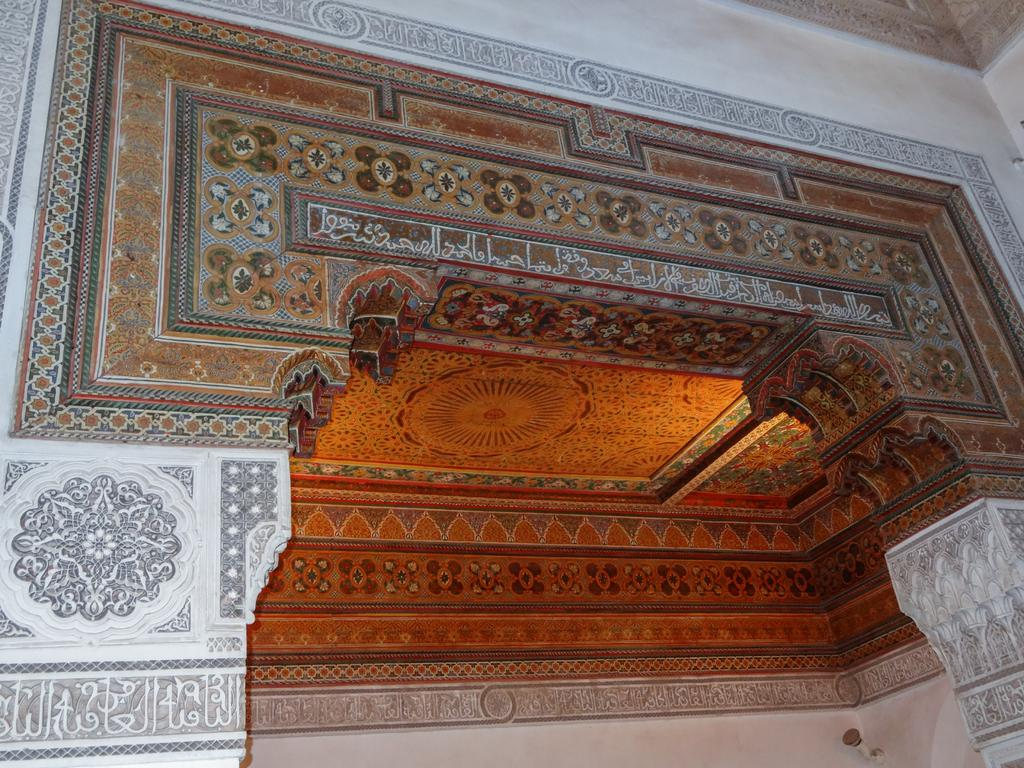What type of structure is present in the image? There is a building in the image. What can be seen on the wall of the building? There is text on the wall of the building. What language is the text written in? The text is in Urdu. What part of the building is visible in the image? There is a ceiling visible in the image. What type of punishment is being administered to the pets in the image? There are no pets present in the image, and therefore no punishment is being administered. What type of rhythm can be heard in the image? There is no sound or music present in the image, so it is not possible to determine any rhythm. 